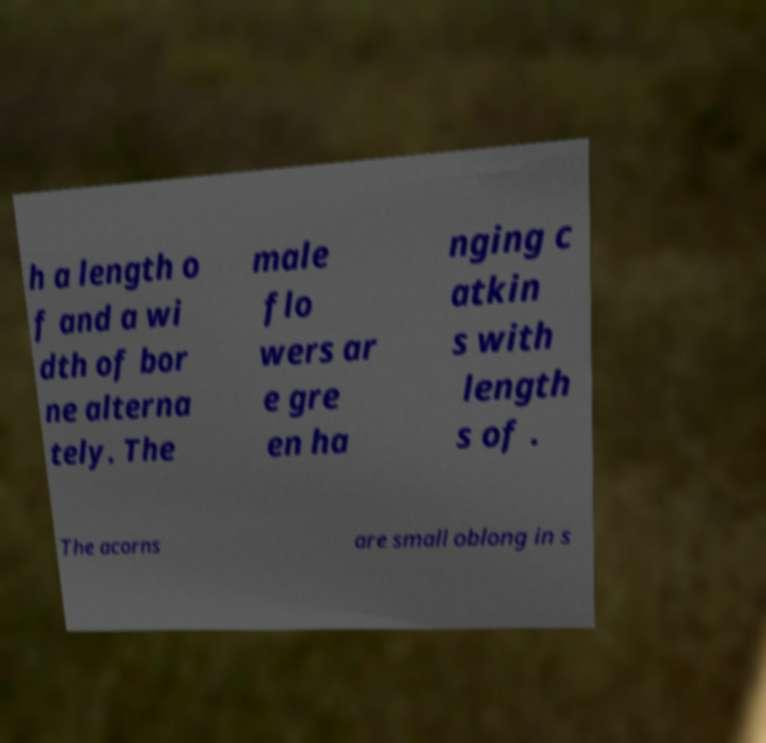Could you assist in decoding the text presented in this image and type it out clearly? h a length o f and a wi dth of bor ne alterna tely. The male flo wers ar e gre en ha nging c atkin s with length s of . The acorns are small oblong in s 